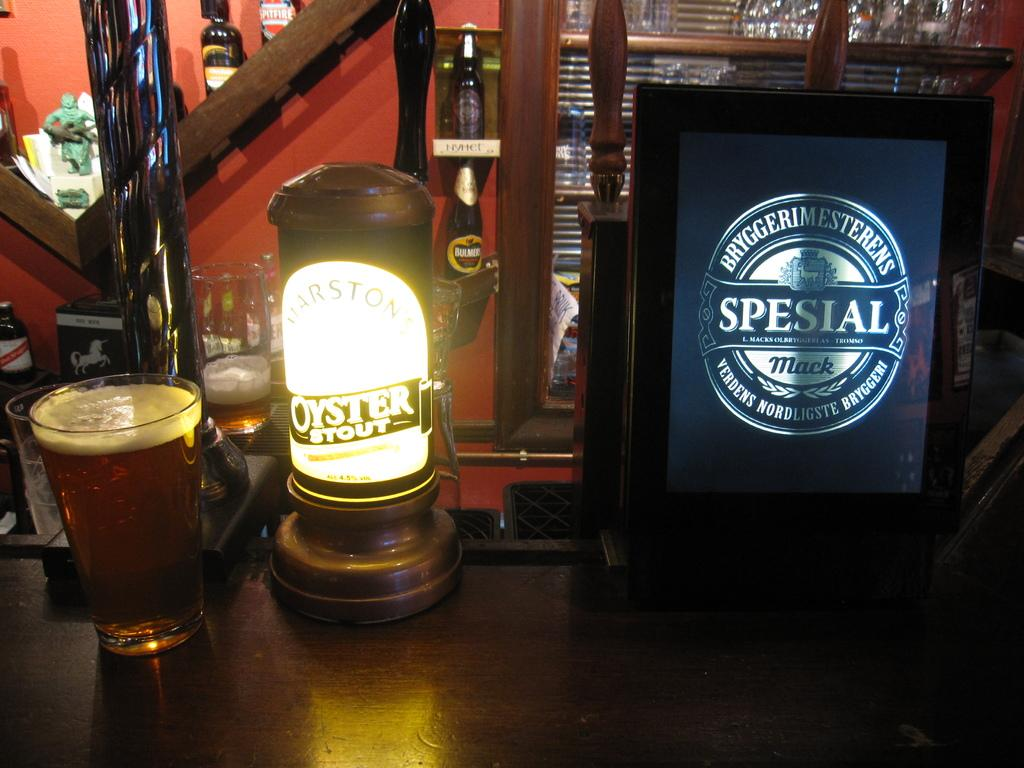<image>
Describe the image concisely. A glass of foamy beer next to a lit up sign that says Oyster Stout. 